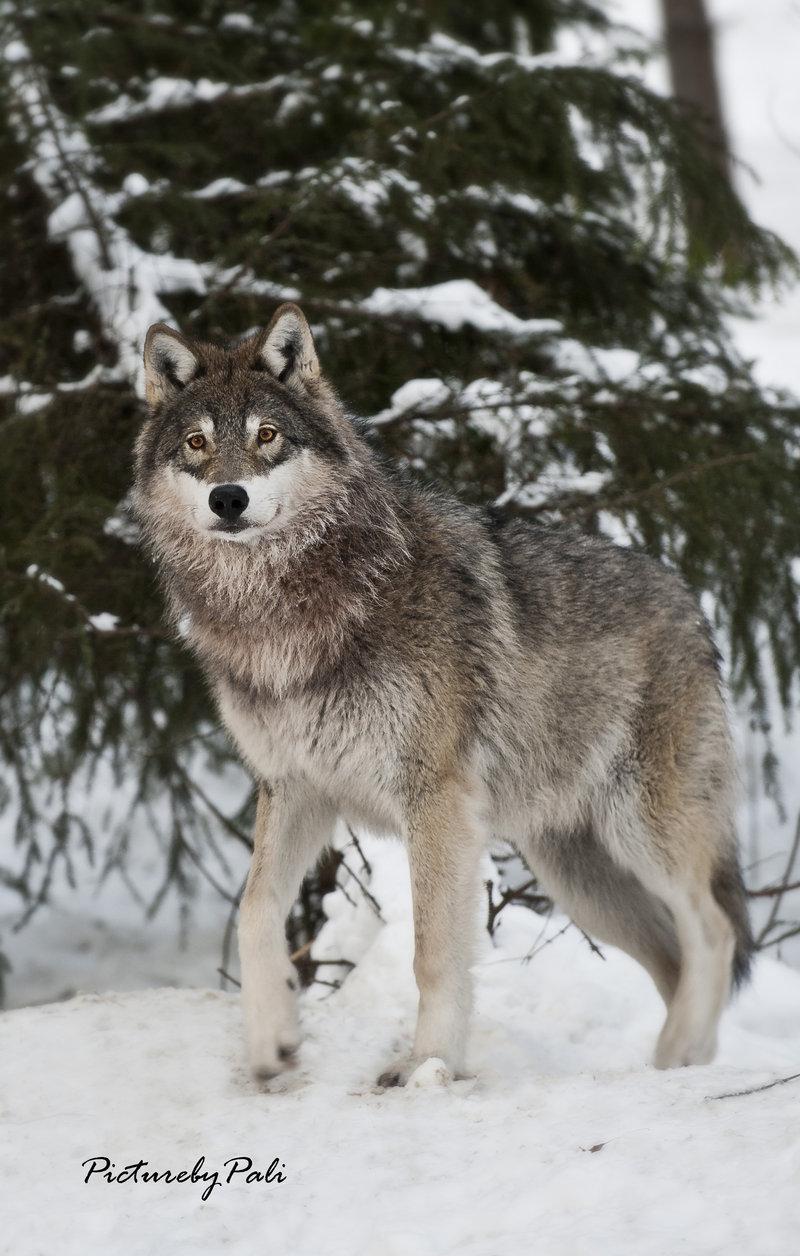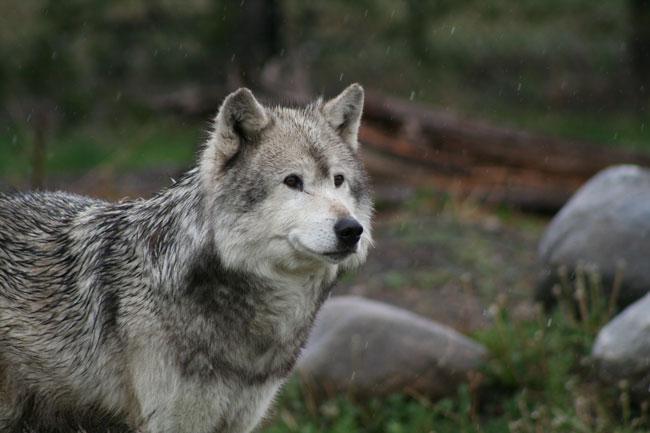The first image is the image on the left, the second image is the image on the right. Evaluate the accuracy of this statement regarding the images: "One image shows a wolf in a snowy scene.". Is it true? Answer yes or no. Yes. The first image is the image on the left, the second image is the image on the right. Given the left and right images, does the statement "There is one young wolf in one of the images." hold true? Answer yes or no. Yes. 